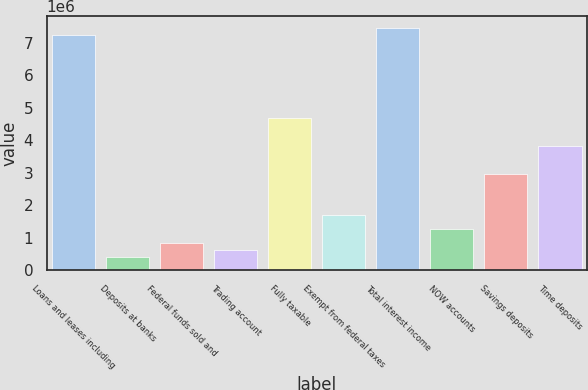Convert chart. <chart><loc_0><loc_0><loc_500><loc_500><bar_chart><fcel>Loans and leases including<fcel>Deposits at banks<fcel>Federal funds sold and<fcel>Trading account<fcel>Fully taxable<fcel>Exempt from federal taxes<fcel>Total interest income<fcel>NOW accounts<fcel>Savings deposits<fcel>Time deposits<nl><fcel>7.23031e+06<fcel>425317<fcel>850629<fcel>637973<fcel>4.67844e+06<fcel>1.70125e+06<fcel>7.44296e+06<fcel>1.27594e+06<fcel>2.97719e+06<fcel>3.82781e+06<nl></chart> 